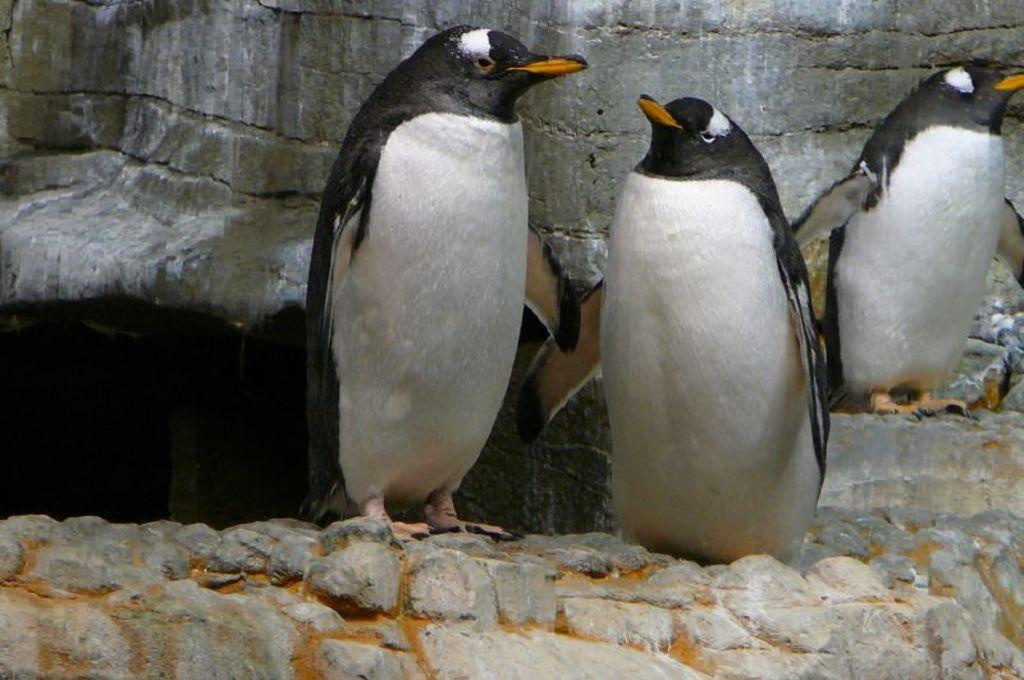What type of animals are in the image? There are penguins in the image. Where are the penguins located? The penguins are on rocks. What can be seen in the background of the image? There is a wall in the background of the image. What is the condition of the town in the image? There is no town present in the image; it features penguins on rocks with a wall in the background. How does the memory of the penguins affect the image? The image does not depict a memory or any subjective experience; it is a static representation of penguins on rocks with a wall in the background. 